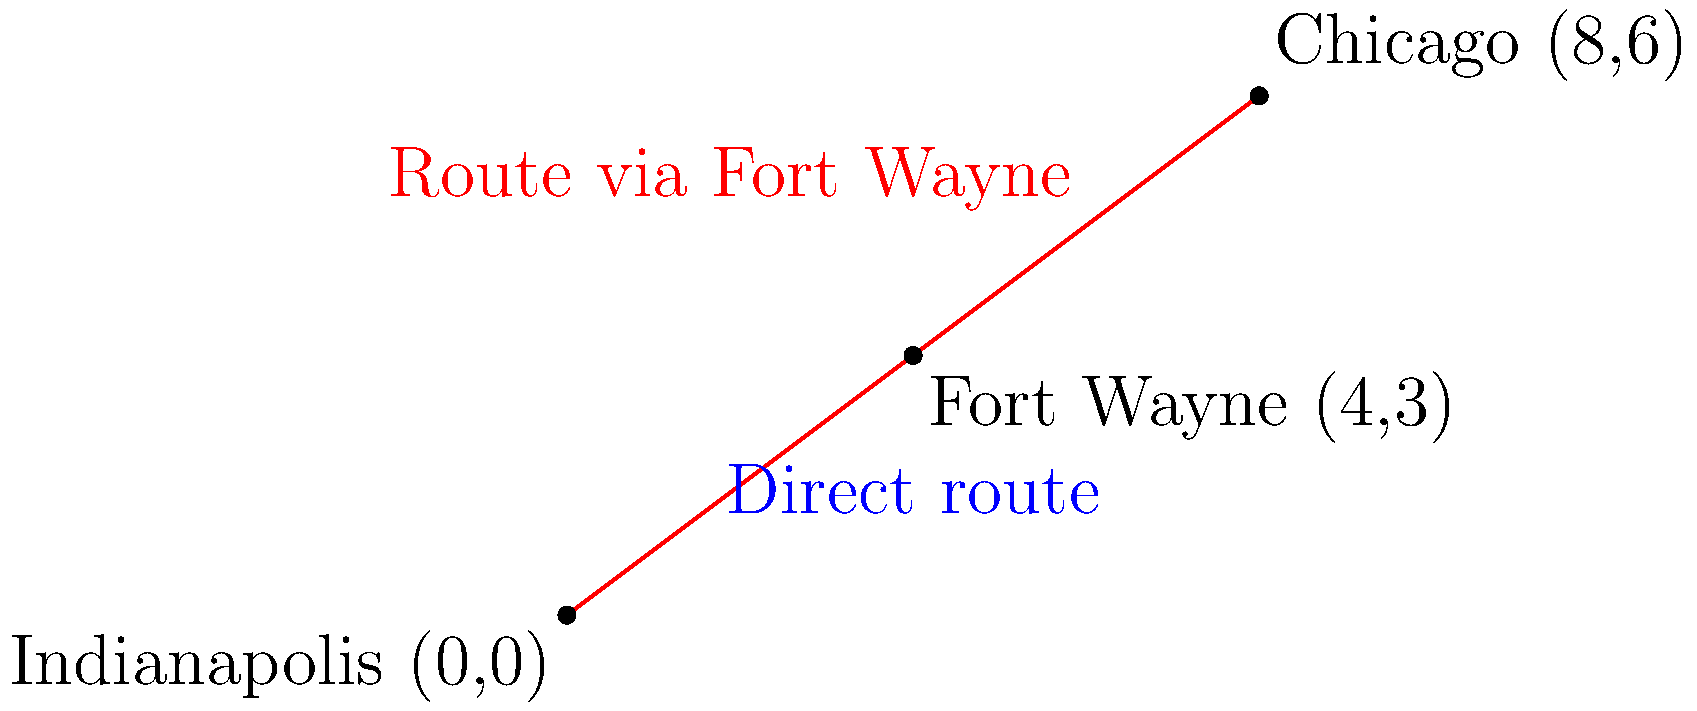As a budget traveler from Indianapolis, you're planning a trip to Chicago. The map shows Indianapolis at (0,0), Chicago at (8,6), and Fort Wayne at (4,3). You're considering either flying directly to Chicago or taking a bus to Fort Wayne and then to Chicago. Using coordinate geometry, determine which route is shorter and by how many units? Let's solve this step-by-step:

1) Direct route (Indianapolis to Chicago):
   Using the distance formula: $d = \sqrt{(x_2-x_1)^2 + (y_2-y_1)^2}$
   $d_{IC} = \sqrt{(8-0)^2 + (6-0)^2} = \sqrt{64 + 36} = \sqrt{100} = 10$ units

2) Route via Fort Wayne:
   Indianapolis to Fort Wayne:
   $d_{IF} = \sqrt{(4-0)^2 + (3-0)^2} = \sqrt{16 + 9} = \sqrt{25} = 5$ units

   Fort Wayne to Chicago:
   $d_{FC} = \sqrt{(8-4)^2 + (6-3)^2} = \sqrt{16 + 9} = \sqrt{25} = 5$ units

   Total distance via Fort Wayne = $5 + 5 = 10$ units

3) Comparison:
   Direct route: 10 units
   Route via Fort Wayne: 10 units

Both routes are equal in distance.
Answer: Both routes are equal at 10 units. 